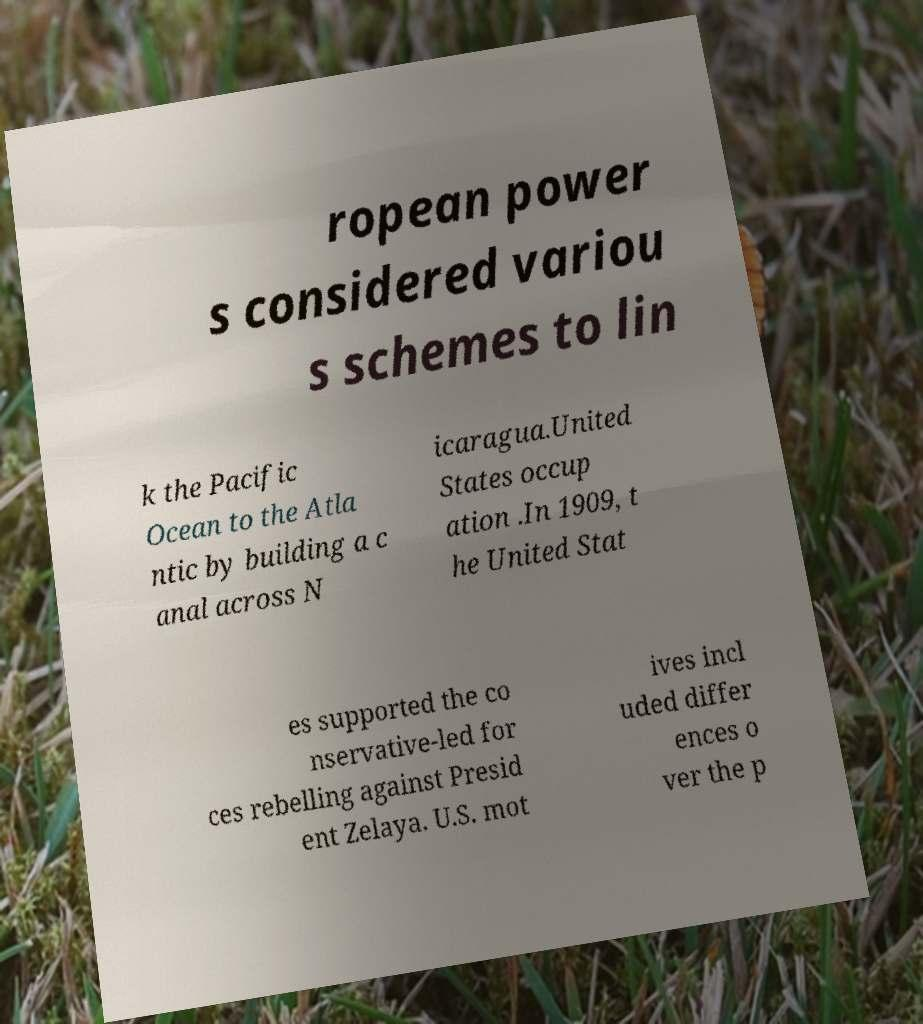I need the written content from this picture converted into text. Can you do that? ropean power s considered variou s schemes to lin k the Pacific Ocean to the Atla ntic by building a c anal across N icaragua.United States occup ation .In 1909, t he United Stat es supported the co nservative-led for ces rebelling against Presid ent Zelaya. U.S. mot ives incl uded differ ences o ver the p 